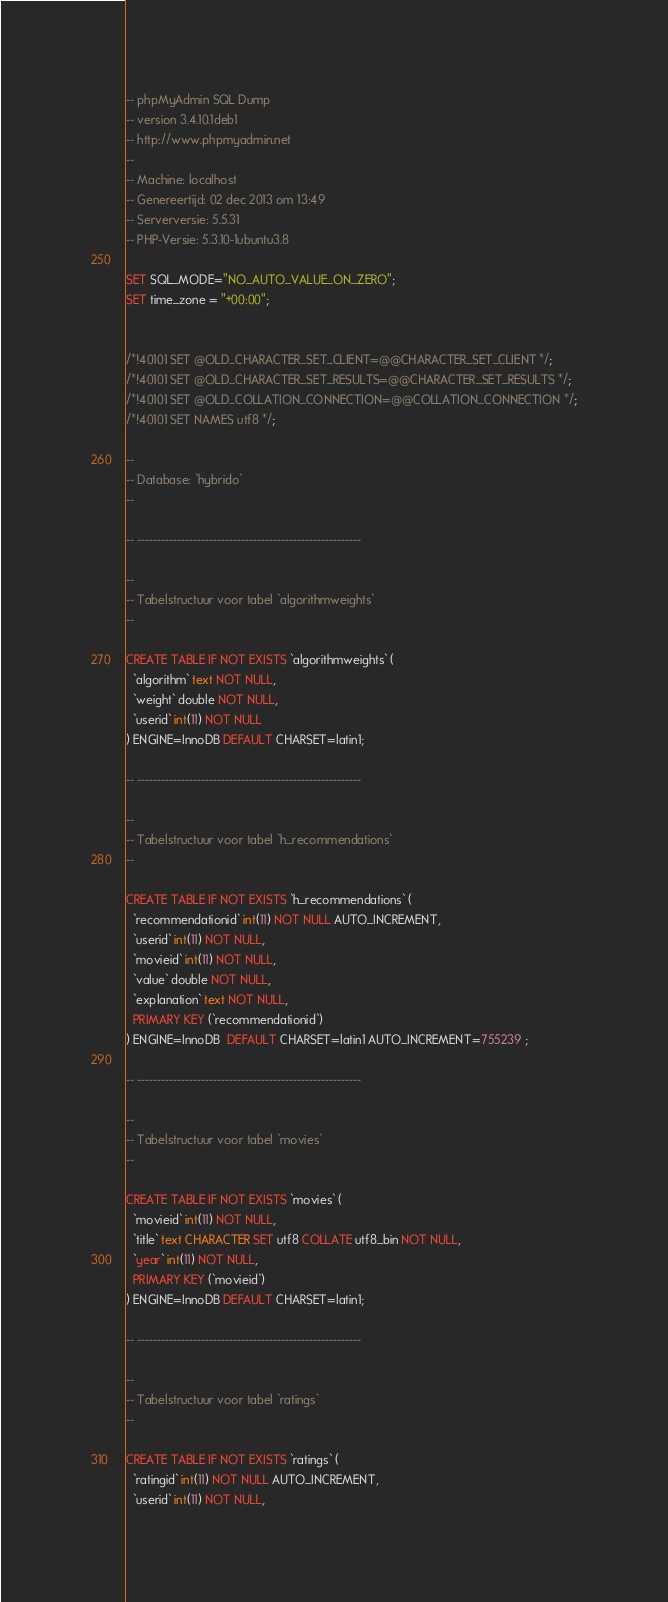<code> <loc_0><loc_0><loc_500><loc_500><_SQL_>-- phpMyAdmin SQL Dump
-- version 3.4.10.1deb1
-- http://www.phpmyadmin.net
--
-- Machine: localhost
-- Genereertijd: 02 dec 2013 om 13:49
-- Serverversie: 5.5.31
-- PHP-Versie: 5.3.10-1ubuntu3.8

SET SQL_MODE="NO_AUTO_VALUE_ON_ZERO";
SET time_zone = "+00:00";


/*!40101 SET @OLD_CHARACTER_SET_CLIENT=@@CHARACTER_SET_CLIENT */;
/*!40101 SET @OLD_CHARACTER_SET_RESULTS=@@CHARACTER_SET_RESULTS */;
/*!40101 SET @OLD_COLLATION_CONNECTION=@@COLLATION_CONNECTION */;
/*!40101 SET NAMES utf8 */;

--
-- Database: `hybrido`
--

-- --------------------------------------------------------

--
-- Tabelstructuur voor tabel `algorithmweights`
--

CREATE TABLE IF NOT EXISTS `algorithmweights` (
  `algorithm` text NOT NULL,
  `weight` double NOT NULL,
  `userid` int(11) NOT NULL
) ENGINE=InnoDB DEFAULT CHARSET=latin1;

-- --------------------------------------------------------

--
-- Tabelstructuur voor tabel `h_recommendations`
--

CREATE TABLE IF NOT EXISTS `h_recommendations` (
  `recommendationid` int(11) NOT NULL AUTO_INCREMENT,
  `userid` int(11) NOT NULL,
  `movieid` int(11) NOT NULL,
  `value` double NOT NULL,
  `explanation` text NOT NULL,
  PRIMARY KEY (`recommendationid`)
) ENGINE=InnoDB  DEFAULT CHARSET=latin1 AUTO_INCREMENT=755239 ;

-- --------------------------------------------------------

--
-- Tabelstructuur voor tabel `movies`
--

CREATE TABLE IF NOT EXISTS `movies` (
  `movieid` int(11) NOT NULL,
  `title` text CHARACTER SET utf8 COLLATE utf8_bin NOT NULL,
  `year` int(11) NOT NULL,
  PRIMARY KEY (`movieid`)
) ENGINE=InnoDB DEFAULT CHARSET=latin1;

-- --------------------------------------------------------

--
-- Tabelstructuur voor tabel `ratings`
--

CREATE TABLE IF NOT EXISTS `ratings` (
  `ratingid` int(11) NOT NULL AUTO_INCREMENT,
  `userid` int(11) NOT NULL,</code> 